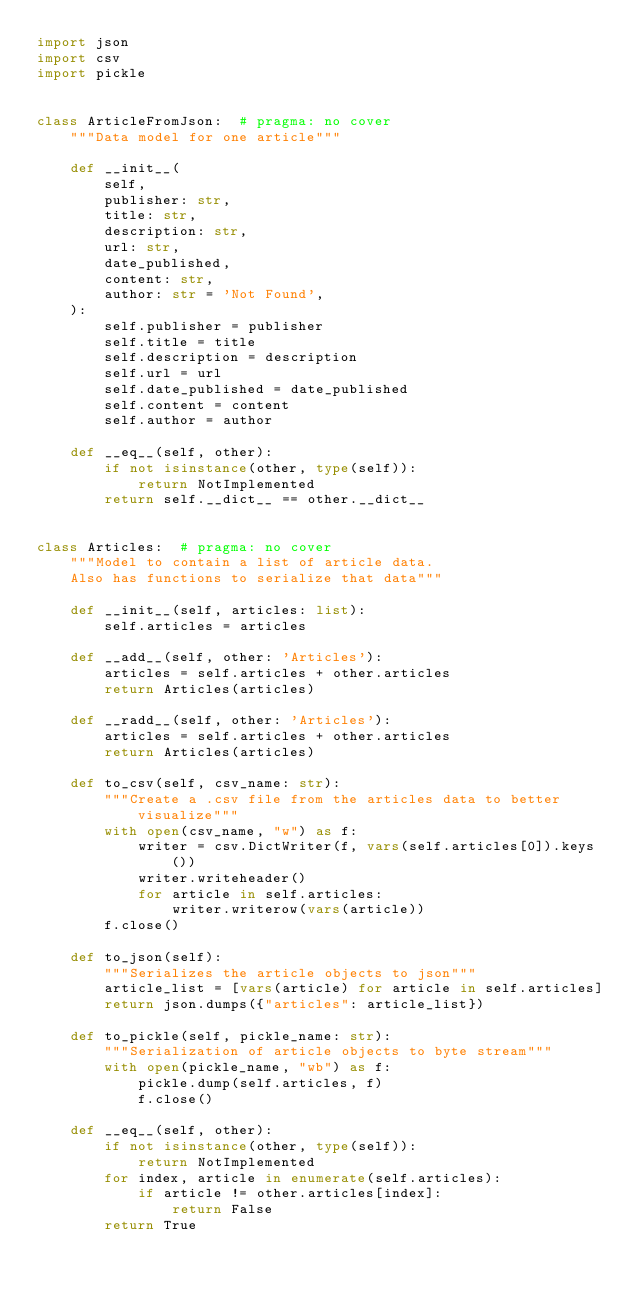Convert code to text. <code><loc_0><loc_0><loc_500><loc_500><_Python_>import json
import csv
import pickle


class ArticleFromJson:  # pragma: no cover
    """Data model for one article"""

    def __init__(
        self,
        publisher: str,
        title: str,
        description: str,
        url: str,
        date_published,
        content: str,
        author: str = 'Not Found',
    ):
        self.publisher = publisher
        self.title = title
        self.description = description
        self.url = url
        self.date_published = date_published
        self.content = content
        self.author = author

    def __eq__(self, other):
        if not isinstance(other, type(self)):
            return NotImplemented
        return self.__dict__ == other.__dict__


class Articles:  # pragma: no cover
    """Model to contain a list of article data.
    Also has functions to serialize that data"""

    def __init__(self, articles: list):
        self.articles = articles

    def __add__(self, other: 'Articles'):
        articles = self.articles + other.articles
        return Articles(articles)

    def __radd__(self, other: 'Articles'):
        articles = self.articles + other.articles
        return Articles(articles)

    def to_csv(self, csv_name: str):
        """Create a .csv file from the articles data to better visualize"""
        with open(csv_name, "w") as f:
            writer = csv.DictWriter(f, vars(self.articles[0]).keys())
            writer.writeheader()
            for article in self.articles:
                writer.writerow(vars(article))
        f.close()

    def to_json(self):
        """Serializes the article objects to json"""
        article_list = [vars(article) for article in self.articles]
        return json.dumps({"articles": article_list})

    def to_pickle(self, pickle_name: str):
        """Serialization of article objects to byte stream"""
        with open(pickle_name, "wb") as f:
            pickle.dump(self.articles, f)
            f.close()

    def __eq__(self, other):
        if not isinstance(other, type(self)):
            return NotImplemented
        for index, article in enumerate(self.articles):
            if article != other.articles[index]:
                return False
        return True
</code> 